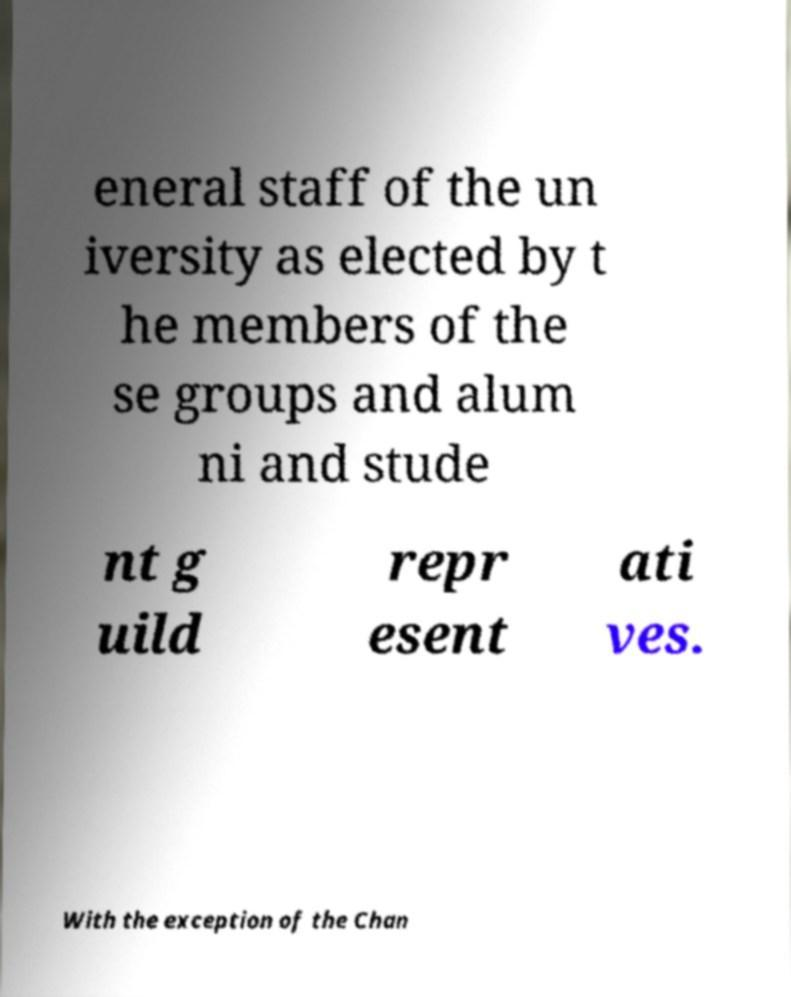Could you assist in decoding the text presented in this image and type it out clearly? eneral staff of the un iversity as elected by t he members of the se groups and alum ni and stude nt g uild repr esent ati ves. With the exception of the Chan 